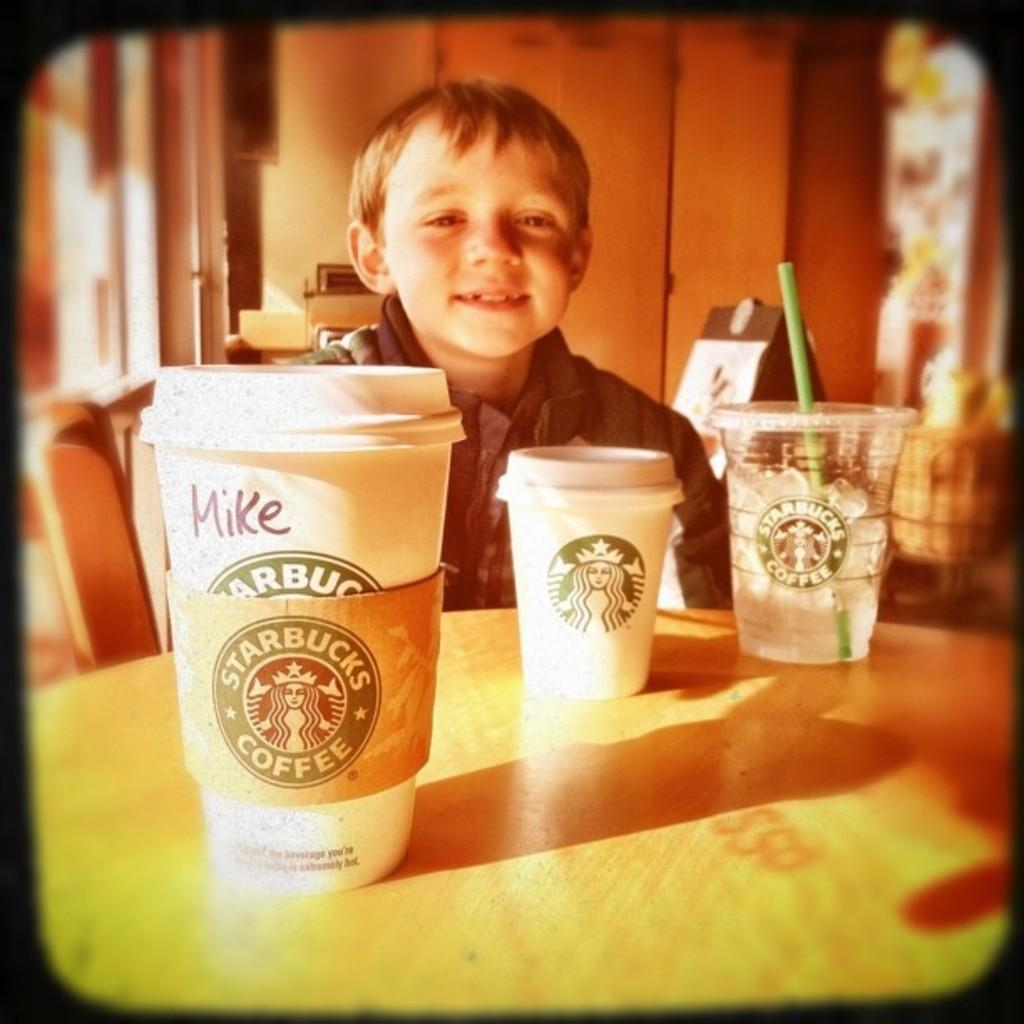<image>
Render a clear and concise summary of the photo. a starbucks coffee cup labeled for a boy named mike 